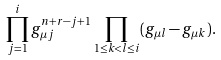<formula> <loc_0><loc_0><loc_500><loc_500>\prod _ { j = 1 } ^ { i } g _ { \mu j } ^ { n + r - j + 1 } \prod _ { 1 \leq k < l \leq i } ( g _ { \mu l } - g _ { \mu k } ) .</formula> 